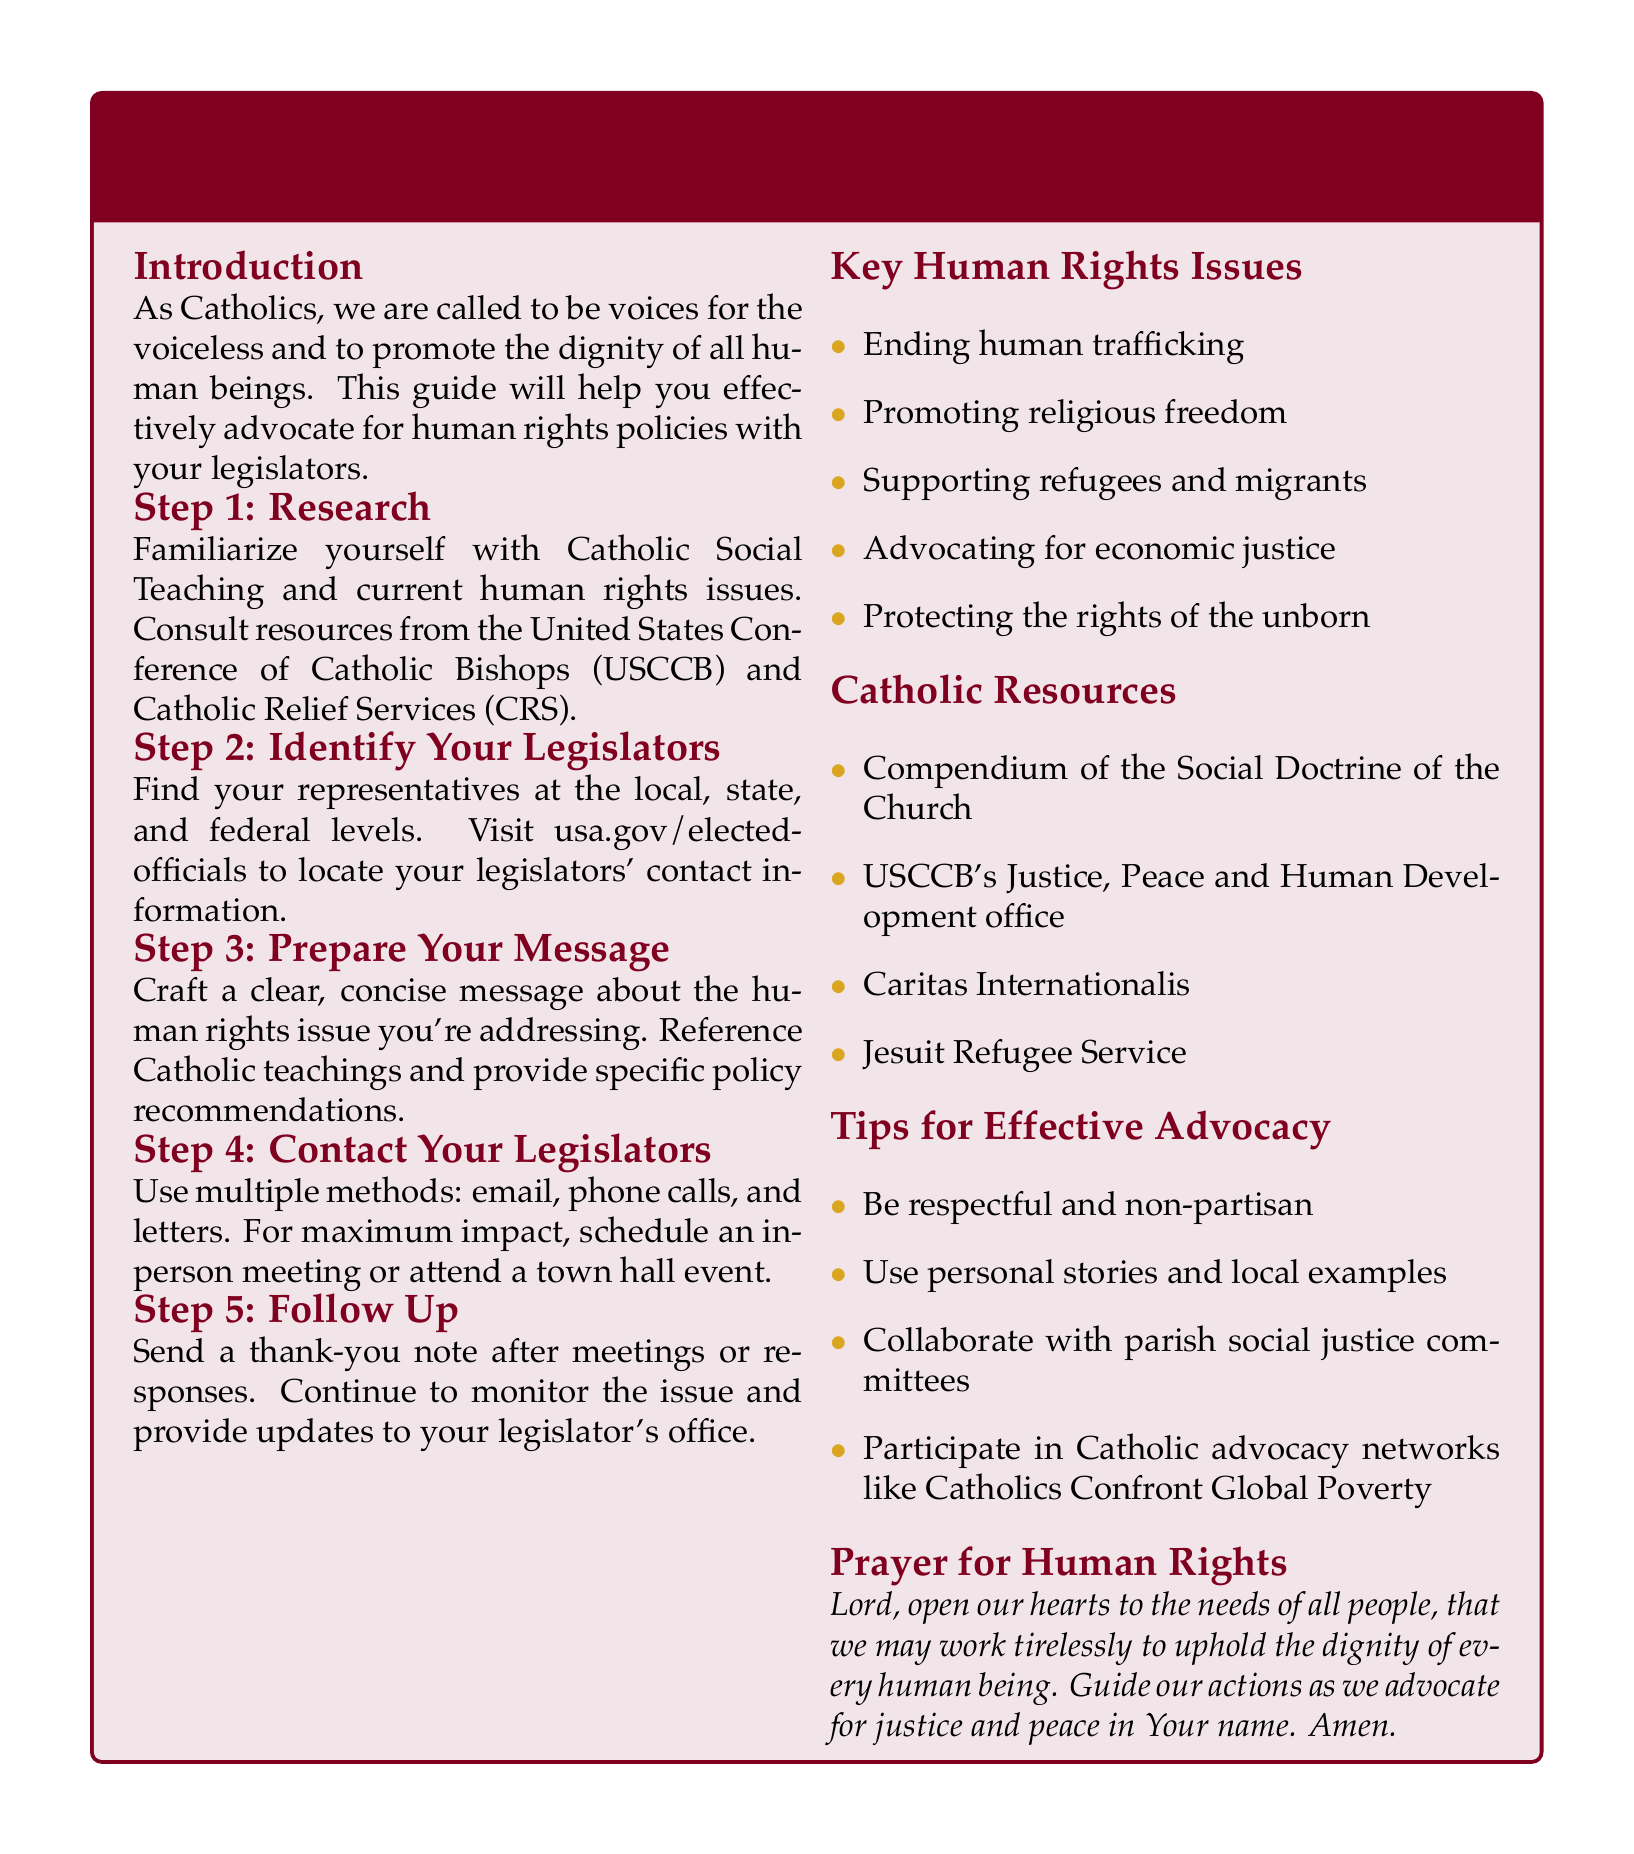What is the title of the brochure? The title summarizes the purpose of the document and is found at the beginning.
Answer: Catholic Advocacy Guide: Promoting Human Rights Through Legislation What is the first step in advocating for human rights? The first step outlined in the guide is about understanding a foundational aspect of advocacy.
Answer: Research What organization is mentioned for resources on human rights issues? The document recommends consulting prominent organizations to assist with advocacy efforts.
Answer: United States Conference of Catholic Bishops (USCCB) How many key human rights issues are listed? The brochure highlights several key concerns, which are important for advocacy work.
Answer: Five What type of tone should advocates use according to the tips? The guide emphasizes a particular approach to communication with legislators.
Answer: Respectful and non-partisan What is a suggested method for contacting legislators? The brochure provides multiple approaches to engaging with lawmakers effectively.
Answer: Email Who is the prayer for in the document? The prayer section focuses on a specific intention that aligns with the document's themes.
Answer: Human rights Which committee does the guide recommend collaborating with? The document suggests working with specific community groups to enhance advocacy efforts.
Answer: Parish social justice committees 